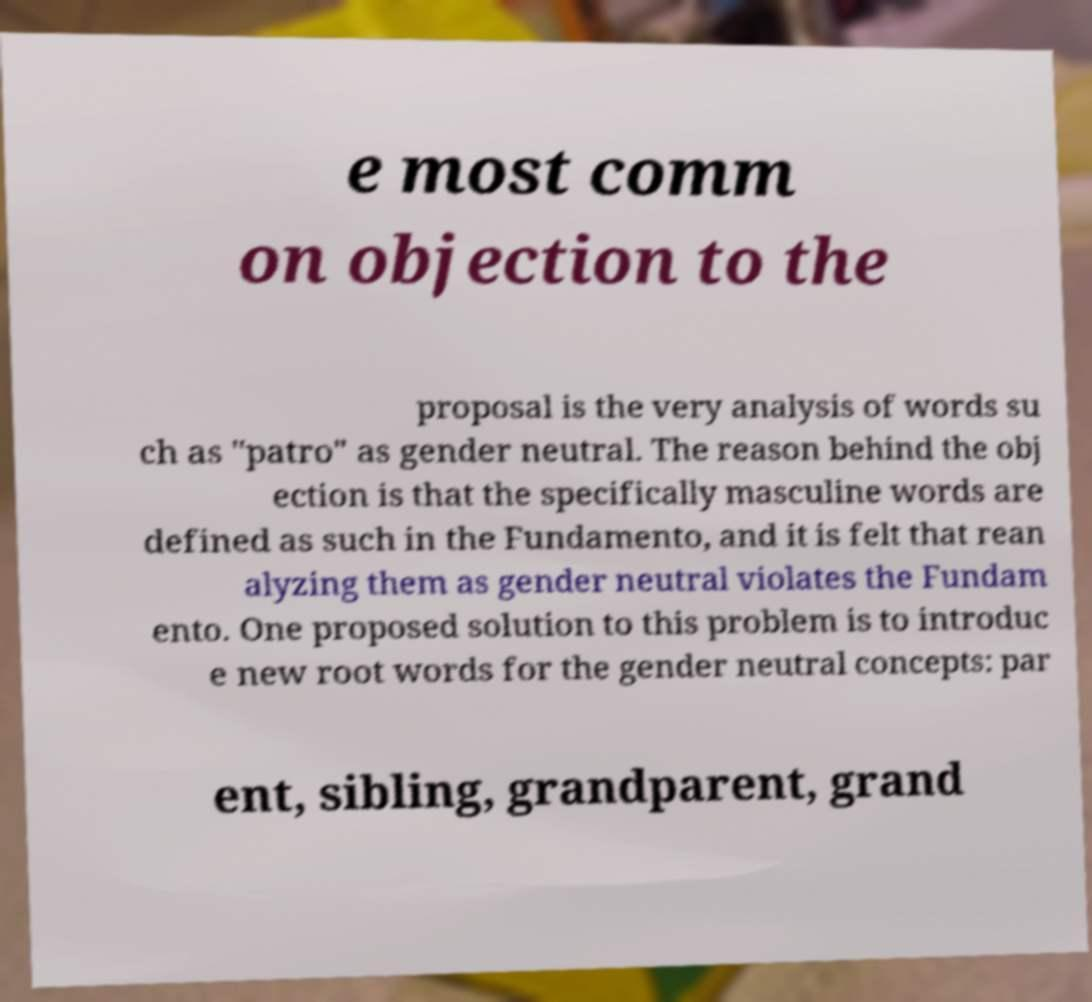Could you assist in decoding the text presented in this image and type it out clearly? e most comm on objection to the proposal is the very analysis of words su ch as "patro" as gender neutral. The reason behind the obj ection is that the specifically masculine words are defined as such in the Fundamento, and it is felt that rean alyzing them as gender neutral violates the Fundam ento. One proposed solution to this problem is to introduc e new root words for the gender neutral concepts: par ent, sibling, grandparent, grand 